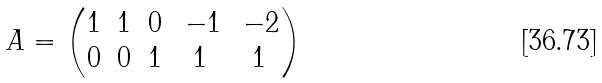Convert formula to latex. <formula><loc_0><loc_0><loc_500><loc_500>A = \begin{pmatrix} 1 & 1 & 0 & \, - 1 & \, - 2 \\ 0 & 0 & 1 & 1 & 1 \end{pmatrix}</formula> 